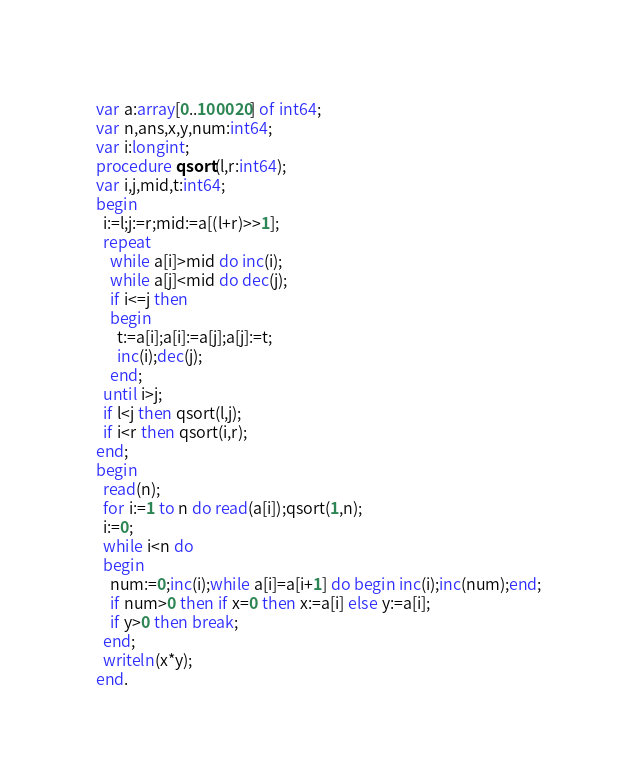<code> <loc_0><loc_0><loc_500><loc_500><_Pascal_>var a:array[0..100020] of int64;
var n,ans,x,y,num:int64;
var i:longint;
procedure qsort(l,r:int64);
var i,j,mid,t:int64;
begin
  i:=l;j:=r;mid:=a[(l+r)>>1];
  repeat
    while a[i]>mid do inc(i);
    while a[j]<mid do dec(j);
    if i<=j then
    begin
      t:=a[i];a[i]:=a[j];a[j]:=t;
      inc(i);dec(j);
    end;
  until i>j;
  if l<j then qsort(l,j);
  if i<r then qsort(i,r);
end;
begin
  read(n);
  for i:=1 to n do read(a[i]);qsort(1,n);
  i:=0;
  while i<n do
  begin
    num:=0;inc(i);while a[i]=a[i+1] do begin inc(i);inc(num);end;
    if num>0 then if x=0 then x:=a[i] else y:=a[i];
    if y>0 then break;
  end;
  writeln(x*y);
end.
</code> 